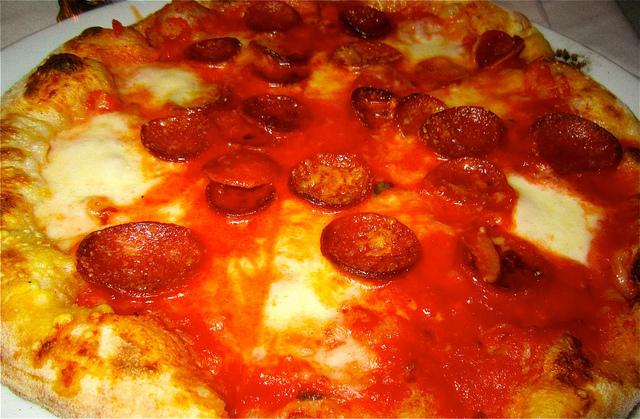Is this pizza likely from a pizzeria?
Quick response, please. Yes. How many slices of pepperoni are there?
Keep it brief. 20. Are there mushrooms on this pizza?
Short answer required. No. Are there any mushrooms on the pizza?
Answer briefly. No. 